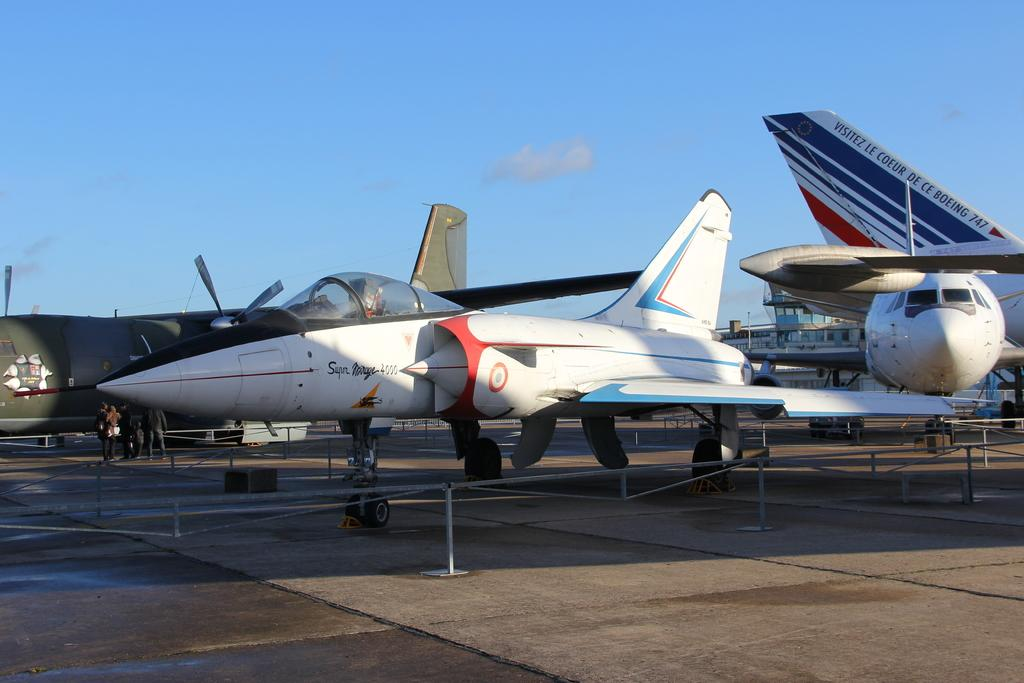<image>
Render a clear and concise summary of the photo. A Super Mirage 4000 jet sitting on a runway. 